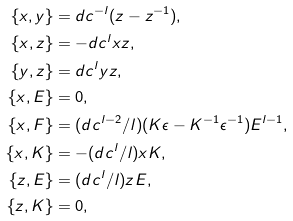<formula> <loc_0><loc_0><loc_500><loc_500>\{ x , y \} & = d c ^ { - l } ( z - z ^ { - 1 } ) , \\ \{ x , z \} & = - d c ^ { l } x z , \\ \{ y , z \} & = d c ^ { l } y z , \\ \{ x , E \} & = 0 , \\ \{ x , F \} & = ( d c ^ { l - 2 } / l ) ( K \epsilon - K ^ { - 1 } \epsilon ^ { - 1 } ) E ^ { l - 1 } , \\ \{ x , K \} & = - ( d c ^ { l } / l ) x K , \\ \{ z , E \} & = ( d c ^ { l } / l ) z E , \\ \{ z , K \} & = 0 ,</formula> 